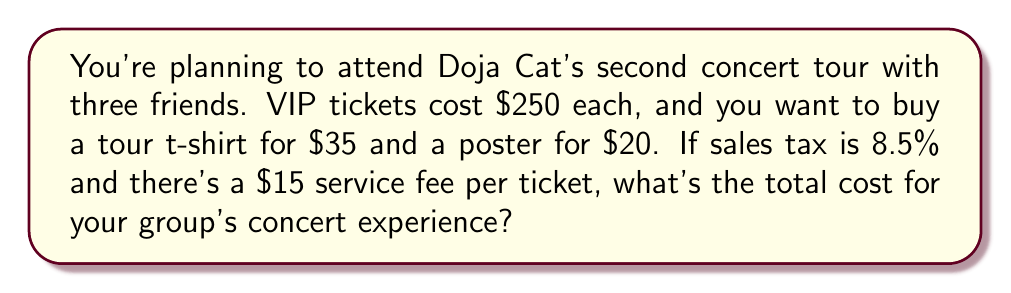Could you help me with this problem? Let's break this down step-by-step:

1. Calculate the base cost of tickets:
   $250 \times 4 = $1000$

2. Add service fees:
   $15 \times 4 = $60$
   Total ticket cost: $1000 + $60 = $1060$

3. Calculate merchandise cost:
   T-shirt: $35
   Poster: $20
   Total merchandise: $35 + $20 = $55$

4. Sum up tickets and merchandise:
   $1060 + $55 = $1115$

5. Calculate sales tax:
   $1115 \times 0.085 = $94.775$

6. Add tax to the total:
   $1115 + $94.775 = $1209.775$

The final amount is $1209.775, which rounds to $1209.78.
Answer: $1209.78 